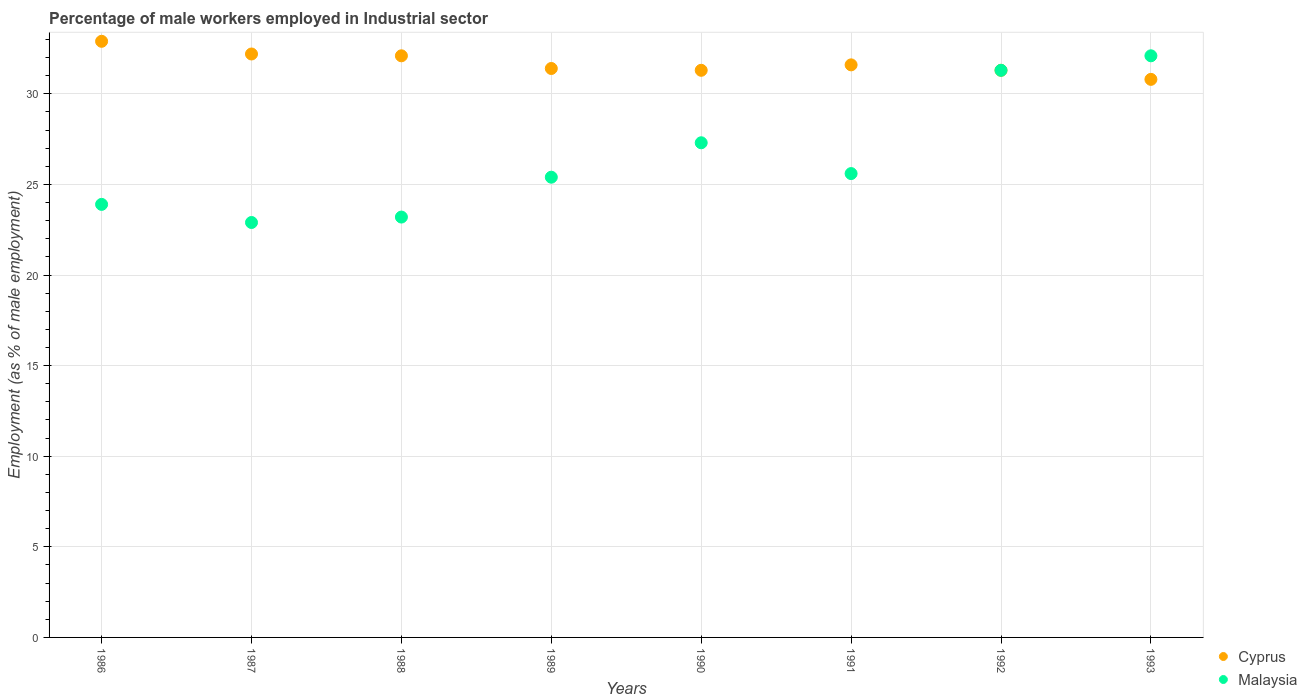How many different coloured dotlines are there?
Your answer should be compact. 2. What is the percentage of male workers employed in Industrial sector in Cyprus in 1987?
Ensure brevity in your answer.  32.2. Across all years, what is the maximum percentage of male workers employed in Industrial sector in Cyprus?
Your response must be concise. 32.9. Across all years, what is the minimum percentage of male workers employed in Industrial sector in Malaysia?
Provide a short and direct response. 22.9. In which year was the percentage of male workers employed in Industrial sector in Cyprus minimum?
Your response must be concise. 1993. What is the total percentage of male workers employed in Industrial sector in Malaysia in the graph?
Offer a terse response. 211.7. What is the difference between the percentage of male workers employed in Industrial sector in Malaysia in 1987 and that in 1988?
Offer a very short reply. -0.3. What is the difference between the percentage of male workers employed in Industrial sector in Cyprus in 1991 and the percentage of male workers employed in Industrial sector in Malaysia in 1990?
Keep it short and to the point. 4.3. What is the average percentage of male workers employed in Industrial sector in Cyprus per year?
Provide a short and direct response. 31.7. In the year 1987, what is the difference between the percentage of male workers employed in Industrial sector in Malaysia and percentage of male workers employed in Industrial sector in Cyprus?
Your answer should be compact. -9.3. What is the ratio of the percentage of male workers employed in Industrial sector in Cyprus in 1986 to that in 1988?
Your response must be concise. 1.02. Is the difference between the percentage of male workers employed in Industrial sector in Malaysia in 1987 and 1989 greater than the difference between the percentage of male workers employed in Industrial sector in Cyprus in 1987 and 1989?
Provide a succinct answer. No. What is the difference between the highest and the second highest percentage of male workers employed in Industrial sector in Cyprus?
Your answer should be compact. 0.7. What is the difference between the highest and the lowest percentage of male workers employed in Industrial sector in Malaysia?
Your response must be concise. 9.2. In how many years, is the percentage of male workers employed in Industrial sector in Malaysia greater than the average percentage of male workers employed in Industrial sector in Malaysia taken over all years?
Make the answer very short. 3. Does the percentage of male workers employed in Industrial sector in Malaysia monotonically increase over the years?
Your response must be concise. No. Is the percentage of male workers employed in Industrial sector in Cyprus strictly less than the percentage of male workers employed in Industrial sector in Malaysia over the years?
Ensure brevity in your answer.  No. Does the graph contain any zero values?
Provide a succinct answer. No. Where does the legend appear in the graph?
Make the answer very short. Bottom right. How many legend labels are there?
Your response must be concise. 2. What is the title of the graph?
Give a very brief answer. Percentage of male workers employed in Industrial sector. What is the label or title of the Y-axis?
Offer a terse response. Employment (as % of male employment). What is the Employment (as % of male employment) of Cyprus in 1986?
Your answer should be very brief. 32.9. What is the Employment (as % of male employment) of Malaysia in 1986?
Offer a very short reply. 23.9. What is the Employment (as % of male employment) in Cyprus in 1987?
Provide a succinct answer. 32.2. What is the Employment (as % of male employment) in Malaysia in 1987?
Make the answer very short. 22.9. What is the Employment (as % of male employment) in Cyprus in 1988?
Make the answer very short. 32.1. What is the Employment (as % of male employment) in Malaysia in 1988?
Make the answer very short. 23.2. What is the Employment (as % of male employment) in Cyprus in 1989?
Give a very brief answer. 31.4. What is the Employment (as % of male employment) of Malaysia in 1989?
Offer a very short reply. 25.4. What is the Employment (as % of male employment) in Cyprus in 1990?
Offer a very short reply. 31.3. What is the Employment (as % of male employment) in Malaysia in 1990?
Make the answer very short. 27.3. What is the Employment (as % of male employment) in Cyprus in 1991?
Ensure brevity in your answer.  31.6. What is the Employment (as % of male employment) in Malaysia in 1991?
Make the answer very short. 25.6. What is the Employment (as % of male employment) in Cyprus in 1992?
Provide a short and direct response. 31.3. What is the Employment (as % of male employment) of Malaysia in 1992?
Provide a short and direct response. 31.3. What is the Employment (as % of male employment) of Cyprus in 1993?
Ensure brevity in your answer.  30.8. What is the Employment (as % of male employment) of Malaysia in 1993?
Provide a short and direct response. 32.1. Across all years, what is the maximum Employment (as % of male employment) in Cyprus?
Your response must be concise. 32.9. Across all years, what is the maximum Employment (as % of male employment) of Malaysia?
Your answer should be very brief. 32.1. Across all years, what is the minimum Employment (as % of male employment) of Cyprus?
Your answer should be compact. 30.8. Across all years, what is the minimum Employment (as % of male employment) in Malaysia?
Ensure brevity in your answer.  22.9. What is the total Employment (as % of male employment) in Cyprus in the graph?
Give a very brief answer. 253.6. What is the total Employment (as % of male employment) of Malaysia in the graph?
Offer a terse response. 211.7. What is the difference between the Employment (as % of male employment) of Cyprus in 1986 and that in 1987?
Offer a very short reply. 0.7. What is the difference between the Employment (as % of male employment) in Malaysia in 1986 and that in 1987?
Your response must be concise. 1. What is the difference between the Employment (as % of male employment) of Malaysia in 1986 and that in 1988?
Give a very brief answer. 0.7. What is the difference between the Employment (as % of male employment) of Malaysia in 1986 and that in 1990?
Offer a terse response. -3.4. What is the difference between the Employment (as % of male employment) of Malaysia in 1986 and that in 1991?
Make the answer very short. -1.7. What is the difference between the Employment (as % of male employment) of Cyprus in 1986 and that in 1992?
Give a very brief answer. 1.6. What is the difference between the Employment (as % of male employment) of Malaysia in 1986 and that in 1993?
Your answer should be compact. -8.2. What is the difference between the Employment (as % of male employment) in Malaysia in 1987 and that in 1988?
Offer a very short reply. -0.3. What is the difference between the Employment (as % of male employment) of Cyprus in 1987 and that in 1989?
Give a very brief answer. 0.8. What is the difference between the Employment (as % of male employment) of Malaysia in 1987 and that in 1989?
Your answer should be very brief. -2.5. What is the difference between the Employment (as % of male employment) of Cyprus in 1987 and that in 1990?
Offer a very short reply. 0.9. What is the difference between the Employment (as % of male employment) of Malaysia in 1987 and that in 1991?
Offer a terse response. -2.7. What is the difference between the Employment (as % of male employment) in Malaysia in 1987 and that in 1993?
Provide a succinct answer. -9.2. What is the difference between the Employment (as % of male employment) of Malaysia in 1988 and that in 1989?
Your answer should be very brief. -2.2. What is the difference between the Employment (as % of male employment) of Cyprus in 1988 and that in 1990?
Your answer should be compact. 0.8. What is the difference between the Employment (as % of male employment) in Malaysia in 1988 and that in 1990?
Your response must be concise. -4.1. What is the difference between the Employment (as % of male employment) of Cyprus in 1988 and that in 1991?
Keep it short and to the point. 0.5. What is the difference between the Employment (as % of male employment) of Malaysia in 1988 and that in 1991?
Give a very brief answer. -2.4. What is the difference between the Employment (as % of male employment) of Cyprus in 1988 and that in 1992?
Your answer should be very brief. 0.8. What is the difference between the Employment (as % of male employment) in Cyprus in 1989 and that in 1991?
Offer a terse response. -0.2. What is the difference between the Employment (as % of male employment) of Malaysia in 1989 and that in 1992?
Offer a very short reply. -5.9. What is the difference between the Employment (as % of male employment) in Cyprus in 1989 and that in 1993?
Your answer should be very brief. 0.6. What is the difference between the Employment (as % of male employment) in Malaysia in 1990 and that in 1991?
Offer a terse response. 1.7. What is the difference between the Employment (as % of male employment) in Cyprus in 1990 and that in 1993?
Ensure brevity in your answer.  0.5. What is the difference between the Employment (as % of male employment) in Cyprus in 1992 and that in 1993?
Your response must be concise. 0.5. What is the difference between the Employment (as % of male employment) in Malaysia in 1992 and that in 1993?
Your answer should be compact. -0.8. What is the difference between the Employment (as % of male employment) of Cyprus in 1986 and the Employment (as % of male employment) of Malaysia in 1992?
Your answer should be compact. 1.6. What is the difference between the Employment (as % of male employment) of Cyprus in 1987 and the Employment (as % of male employment) of Malaysia in 1993?
Give a very brief answer. 0.1. What is the difference between the Employment (as % of male employment) in Cyprus in 1988 and the Employment (as % of male employment) in Malaysia in 1990?
Give a very brief answer. 4.8. What is the difference between the Employment (as % of male employment) of Cyprus in 1988 and the Employment (as % of male employment) of Malaysia in 1991?
Your answer should be compact. 6.5. What is the difference between the Employment (as % of male employment) in Cyprus in 1988 and the Employment (as % of male employment) in Malaysia in 1992?
Give a very brief answer. 0.8. What is the difference between the Employment (as % of male employment) of Cyprus in 1989 and the Employment (as % of male employment) of Malaysia in 1991?
Your response must be concise. 5.8. What is the difference between the Employment (as % of male employment) in Cyprus in 1989 and the Employment (as % of male employment) in Malaysia in 1992?
Ensure brevity in your answer.  0.1. What is the difference between the Employment (as % of male employment) in Cyprus in 1991 and the Employment (as % of male employment) in Malaysia in 1992?
Your answer should be compact. 0.3. What is the difference between the Employment (as % of male employment) in Cyprus in 1991 and the Employment (as % of male employment) in Malaysia in 1993?
Your answer should be very brief. -0.5. What is the difference between the Employment (as % of male employment) of Cyprus in 1992 and the Employment (as % of male employment) of Malaysia in 1993?
Your response must be concise. -0.8. What is the average Employment (as % of male employment) in Cyprus per year?
Offer a very short reply. 31.7. What is the average Employment (as % of male employment) of Malaysia per year?
Provide a short and direct response. 26.46. In the year 1989, what is the difference between the Employment (as % of male employment) of Cyprus and Employment (as % of male employment) of Malaysia?
Offer a very short reply. 6. In the year 1993, what is the difference between the Employment (as % of male employment) in Cyprus and Employment (as % of male employment) in Malaysia?
Make the answer very short. -1.3. What is the ratio of the Employment (as % of male employment) in Cyprus in 1986 to that in 1987?
Provide a short and direct response. 1.02. What is the ratio of the Employment (as % of male employment) of Malaysia in 1986 to that in 1987?
Provide a short and direct response. 1.04. What is the ratio of the Employment (as % of male employment) in Cyprus in 1986 to that in 1988?
Provide a short and direct response. 1.02. What is the ratio of the Employment (as % of male employment) of Malaysia in 1986 to that in 1988?
Give a very brief answer. 1.03. What is the ratio of the Employment (as % of male employment) of Cyprus in 1986 to that in 1989?
Your response must be concise. 1.05. What is the ratio of the Employment (as % of male employment) of Malaysia in 1986 to that in 1989?
Keep it short and to the point. 0.94. What is the ratio of the Employment (as % of male employment) of Cyprus in 1986 to that in 1990?
Keep it short and to the point. 1.05. What is the ratio of the Employment (as % of male employment) of Malaysia in 1986 to that in 1990?
Give a very brief answer. 0.88. What is the ratio of the Employment (as % of male employment) in Cyprus in 1986 to that in 1991?
Offer a terse response. 1.04. What is the ratio of the Employment (as % of male employment) in Malaysia in 1986 to that in 1991?
Offer a very short reply. 0.93. What is the ratio of the Employment (as % of male employment) of Cyprus in 1986 to that in 1992?
Make the answer very short. 1.05. What is the ratio of the Employment (as % of male employment) in Malaysia in 1986 to that in 1992?
Provide a succinct answer. 0.76. What is the ratio of the Employment (as % of male employment) in Cyprus in 1986 to that in 1993?
Your response must be concise. 1.07. What is the ratio of the Employment (as % of male employment) of Malaysia in 1986 to that in 1993?
Keep it short and to the point. 0.74. What is the ratio of the Employment (as % of male employment) of Cyprus in 1987 to that in 1988?
Give a very brief answer. 1. What is the ratio of the Employment (as % of male employment) of Malaysia in 1987 to that in 1988?
Make the answer very short. 0.99. What is the ratio of the Employment (as % of male employment) of Cyprus in 1987 to that in 1989?
Offer a very short reply. 1.03. What is the ratio of the Employment (as % of male employment) of Malaysia in 1987 to that in 1989?
Offer a terse response. 0.9. What is the ratio of the Employment (as % of male employment) of Cyprus in 1987 to that in 1990?
Give a very brief answer. 1.03. What is the ratio of the Employment (as % of male employment) in Malaysia in 1987 to that in 1990?
Ensure brevity in your answer.  0.84. What is the ratio of the Employment (as % of male employment) of Cyprus in 1987 to that in 1991?
Keep it short and to the point. 1.02. What is the ratio of the Employment (as % of male employment) of Malaysia in 1987 to that in 1991?
Offer a very short reply. 0.89. What is the ratio of the Employment (as % of male employment) in Cyprus in 1987 to that in 1992?
Make the answer very short. 1.03. What is the ratio of the Employment (as % of male employment) of Malaysia in 1987 to that in 1992?
Your answer should be very brief. 0.73. What is the ratio of the Employment (as % of male employment) of Cyprus in 1987 to that in 1993?
Offer a terse response. 1.05. What is the ratio of the Employment (as % of male employment) in Malaysia in 1987 to that in 1993?
Keep it short and to the point. 0.71. What is the ratio of the Employment (as % of male employment) of Cyprus in 1988 to that in 1989?
Make the answer very short. 1.02. What is the ratio of the Employment (as % of male employment) of Malaysia in 1988 to that in 1989?
Your response must be concise. 0.91. What is the ratio of the Employment (as % of male employment) in Cyprus in 1988 to that in 1990?
Your answer should be compact. 1.03. What is the ratio of the Employment (as % of male employment) in Malaysia in 1988 to that in 1990?
Offer a very short reply. 0.85. What is the ratio of the Employment (as % of male employment) of Cyprus in 1988 to that in 1991?
Offer a terse response. 1.02. What is the ratio of the Employment (as % of male employment) of Malaysia in 1988 to that in 1991?
Give a very brief answer. 0.91. What is the ratio of the Employment (as % of male employment) of Cyprus in 1988 to that in 1992?
Ensure brevity in your answer.  1.03. What is the ratio of the Employment (as % of male employment) in Malaysia in 1988 to that in 1992?
Ensure brevity in your answer.  0.74. What is the ratio of the Employment (as % of male employment) of Cyprus in 1988 to that in 1993?
Your answer should be compact. 1.04. What is the ratio of the Employment (as % of male employment) in Malaysia in 1988 to that in 1993?
Give a very brief answer. 0.72. What is the ratio of the Employment (as % of male employment) of Cyprus in 1989 to that in 1990?
Ensure brevity in your answer.  1. What is the ratio of the Employment (as % of male employment) of Malaysia in 1989 to that in 1990?
Give a very brief answer. 0.93. What is the ratio of the Employment (as % of male employment) in Cyprus in 1989 to that in 1991?
Your response must be concise. 0.99. What is the ratio of the Employment (as % of male employment) in Malaysia in 1989 to that in 1991?
Make the answer very short. 0.99. What is the ratio of the Employment (as % of male employment) in Malaysia in 1989 to that in 1992?
Provide a short and direct response. 0.81. What is the ratio of the Employment (as % of male employment) of Cyprus in 1989 to that in 1993?
Provide a succinct answer. 1.02. What is the ratio of the Employment (as % of male employment) in Malaysia in 1989 to that in 1993?
Provide a short and direct response. 0.79. What is the ratio of the Employment (as % of male employment) in Cyprus in 1990 to that in 1991?
Your answer should be compact. 0.99. What is the ratio of the Employment (as % of male employment) in Malaysia in 1990 to that in 1991?
Your response must be concise. 1.07. What is the ratio of the Employment (as % of male employment) of Malaysia in 1990 to that in 1992?
Provide a short and direct response. 0.87. What is the ratio of the Employment (as % of male employment) in Cyprus in 1990 to that in 1993?
Provide a succinct answer. 1.02. What is the ratio of the Employment (as % of male employment) of Malaysia in 1990 to that in 1993?
Provide a succinct answer. 0.85. What is the ratio of the Employment (as % of male employment) in Cyprus in 1991 to that in 1992?
Keep it short and to the point. 1.01. What is the ratio of the Employment (as % of male employment) of Malaysia in 1991 to that in 1992?
Offer a very short reply. 0.82. What is the ratio of the Employment (as % of male employment) of Cyprus in 1991 to that in 1993?
Offer a terse response. 1.03. What is the ratio of the Employment (as % of male employment) of Malaysia in 1991 to that in 1993?
Provide a short and direct response. 0.8. What is the ratio of the Employment (as % of male employment) of Cyprus in 1992 to that in 1993?
Your response must be concise. 1.02. What is the ratio of the Employment (as % of male employment) of Malaysia in 1992 to that in 1993?
Keep it short and to the point. 0.98. What is the difference between the highest and the second highest Employment (as % of male employment) in Cyprus?
Your answer should be very brief. 0.7. 